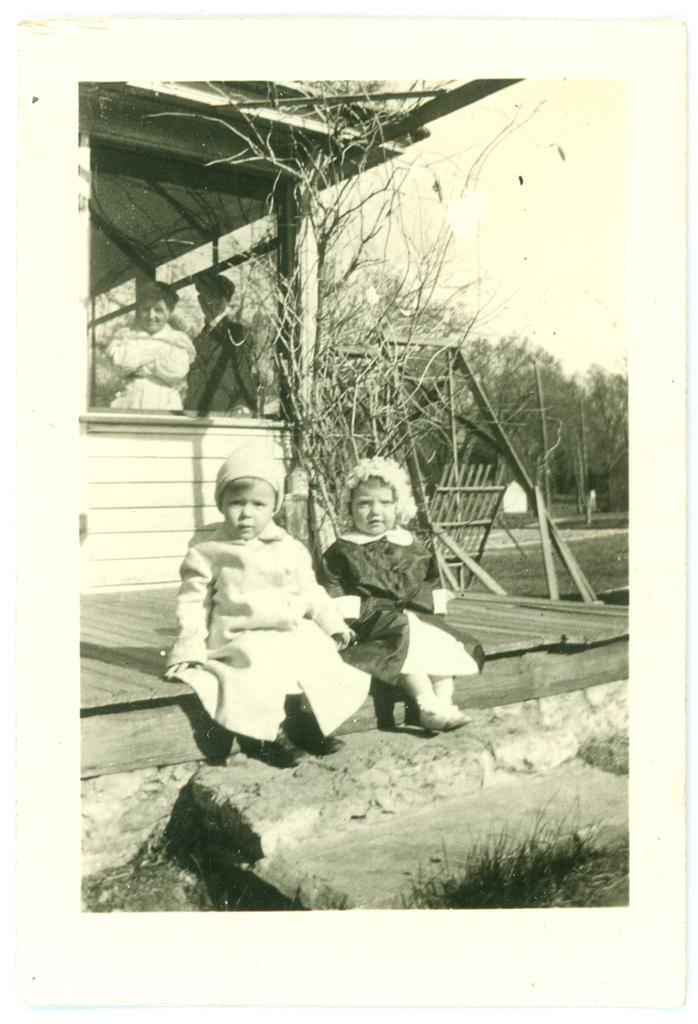What are the kids doing in the front of the image? The kids are sitting in the front of the image. What can be seen in the background of the image? There are trees and persons standing in the background of the image. What type of structure is present in the image? There is a wooden shelter in the image. What is the ground covered with in the image? The ground is covered with grass in the image. What type of vessel is being used by the sheep in the image? There are no sheep present in the image, and therefore no vessel is being used by them. 